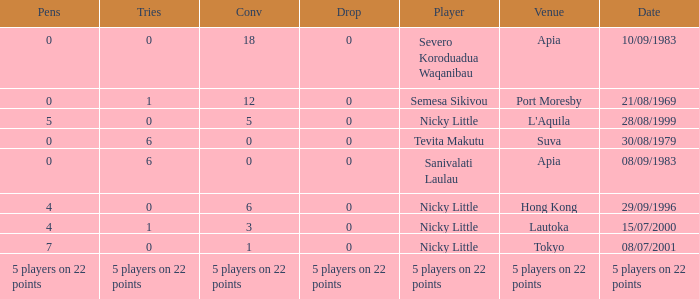How many conversions had 0 pens and 0 tries? 18.0. 